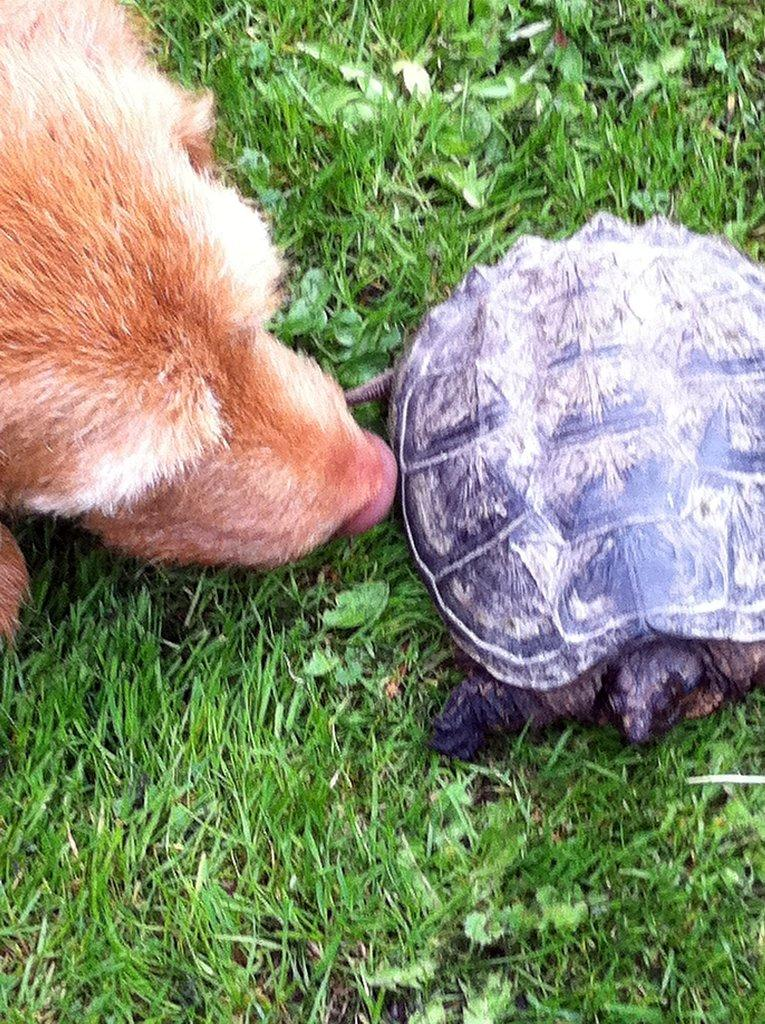What type of animal is in the image? There is a tortoise in the image. Can you describe the environment where the tortoise is located? The tortoise and the animal are on grassland. What other living organisms can be seen in the grassland? There are plants in the grassland. What type of bun is being served for dinner in the image? There is no dinner or bun present in the image; it features a tortoise and plants on grassland. 